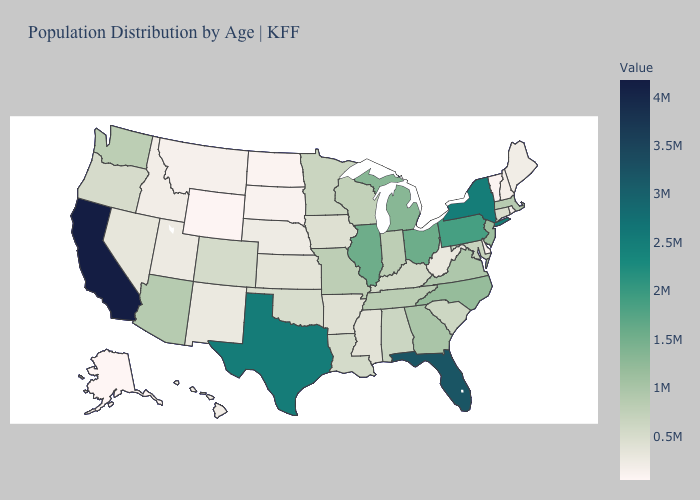Does North Dakota have the lowest value in the MidWest?
Quick response, please. Yes. Among the states that border Massachusetts , which have the lowest value?
Quick response, please. Vermont. Among the states that border Nebraska , does Iowa have the highest value?
Short answer required. No. Among the states that border New York , which have the lowest value?
Be succinct. Vermont. Which states have the highest value in the USA?
Be succinct. California. 